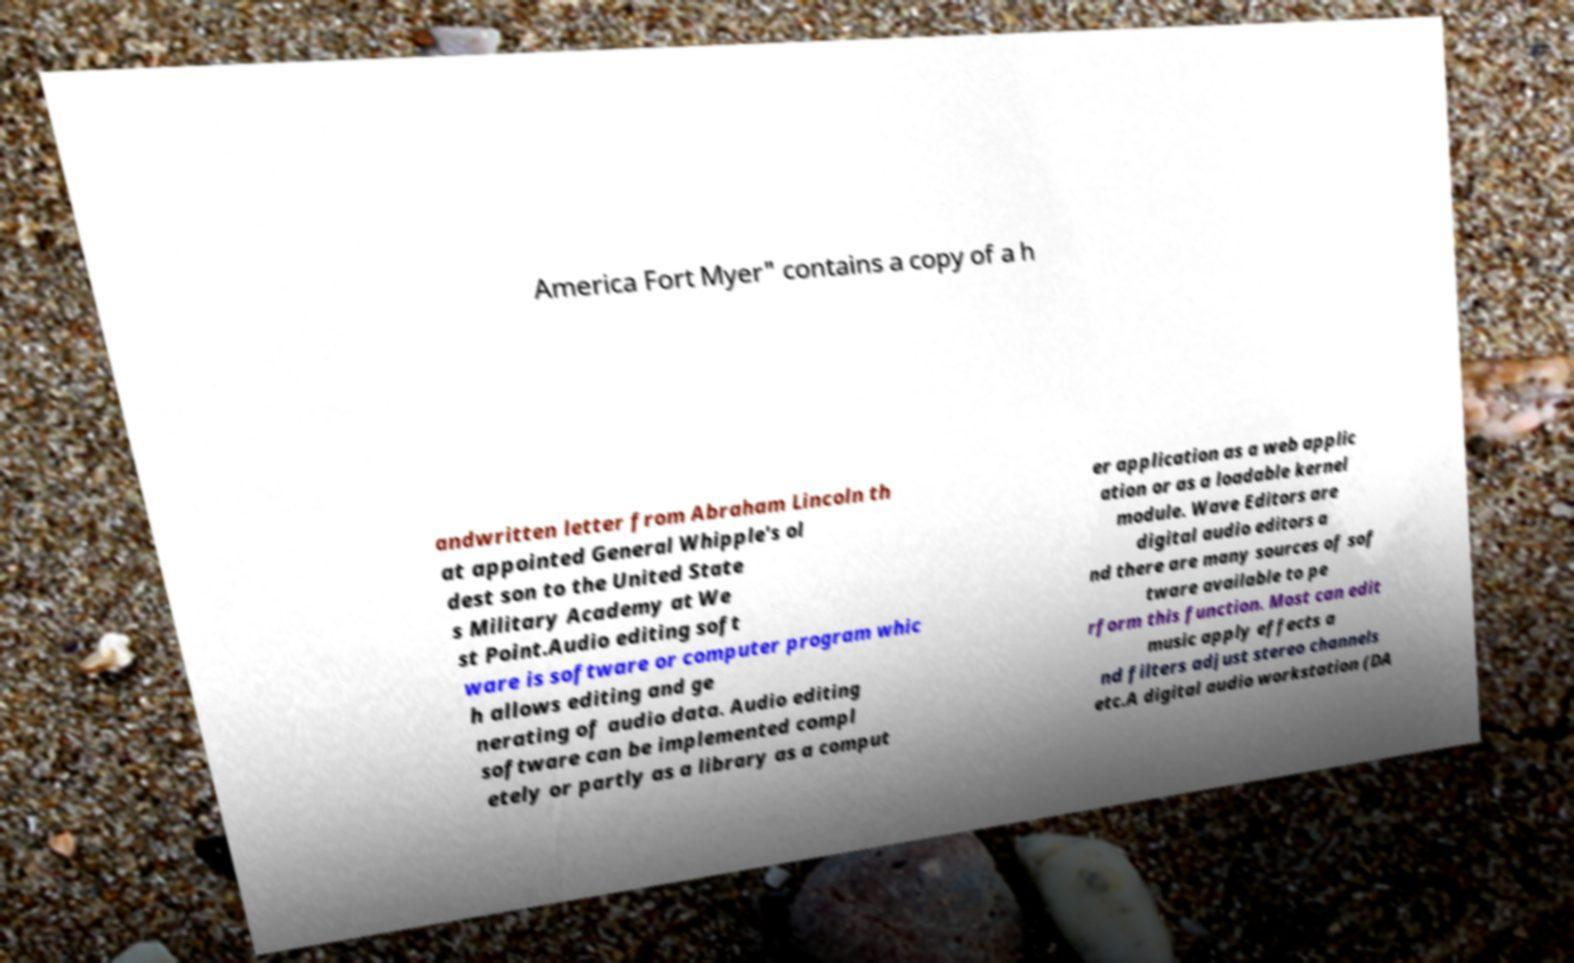Please identify and transcribe the text found in this image. America Fort Myer" contains a copy of a h andwritten letter from Abraham Lincoln th at appointed General Whipple's ol dest son to the United State s Military Academy at We st Point.Audio editing soft ware is software or computer program whic h allows editing and ge nerating of audio data. Audio editing software can be implemented compl etely or partly as a library as a comput er application as a web applic ation or as a loadable kernel module. Wave Editors are digital audio editors a nd there are many sources of sof tware available to pe rform this function. Most can edit music apply effects a nd filters adjust stereo channels etc.A digital audio workstation (DA 